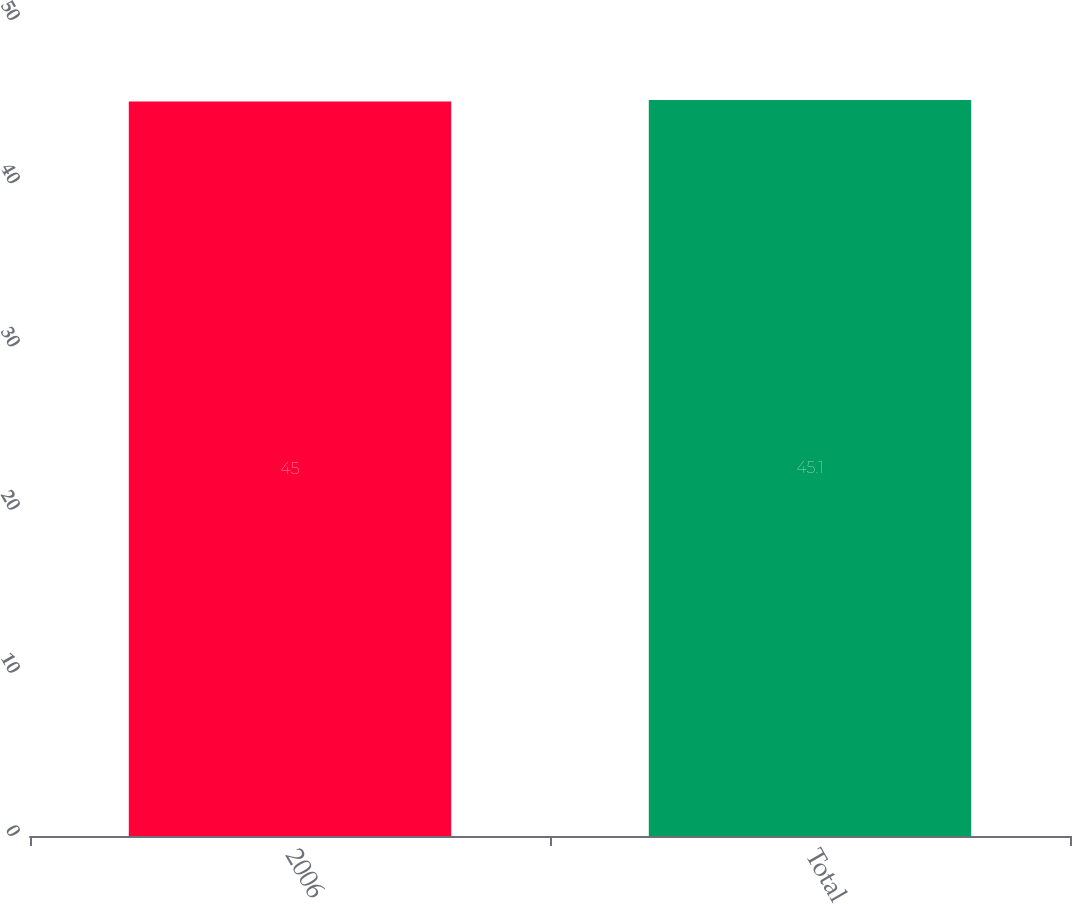<chart> <loc_0><loc_0><loc_500><loc_500><bar_chart><fcel>2006<fcel>Total<nl><fcel>45<fcel>45.1<nl></chart> 